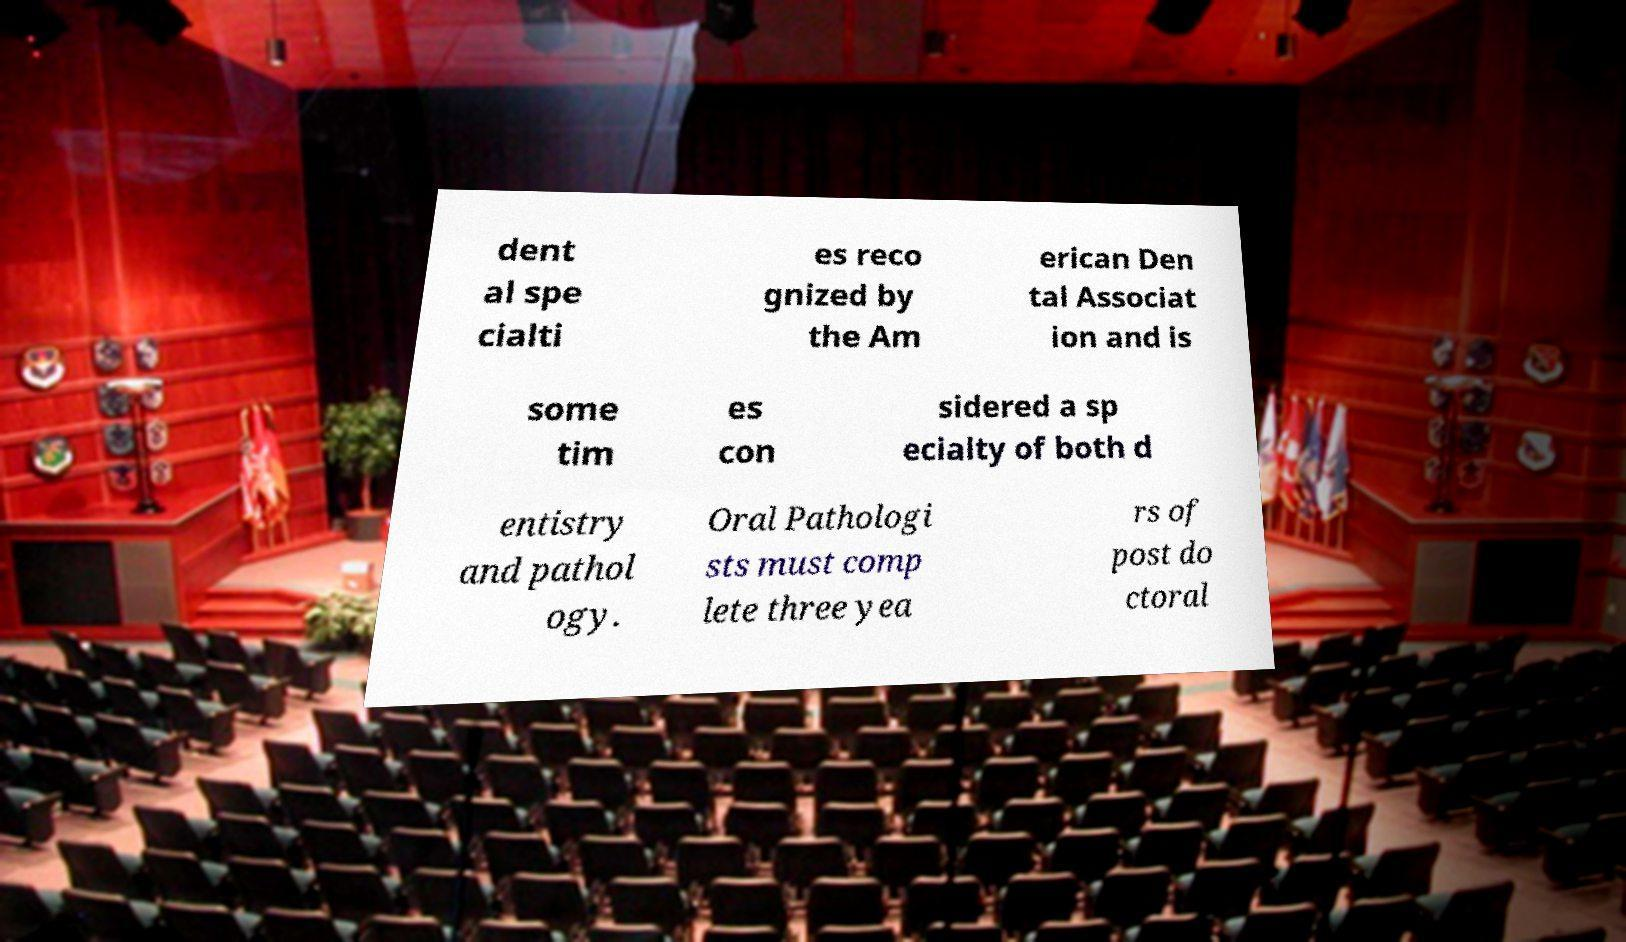Can you read and provide the text displayed in the image?This photo seems to have some interesting text. Can you extract and type it out for me? dent al spe cialti es reco gnized by the Am erican Den tal Associat ion and is some tim es con sidered a sp ecialty of both d entistry and pathol ogy. Oral Pathologi sts must comp lete three yea rs of post do ctoral 